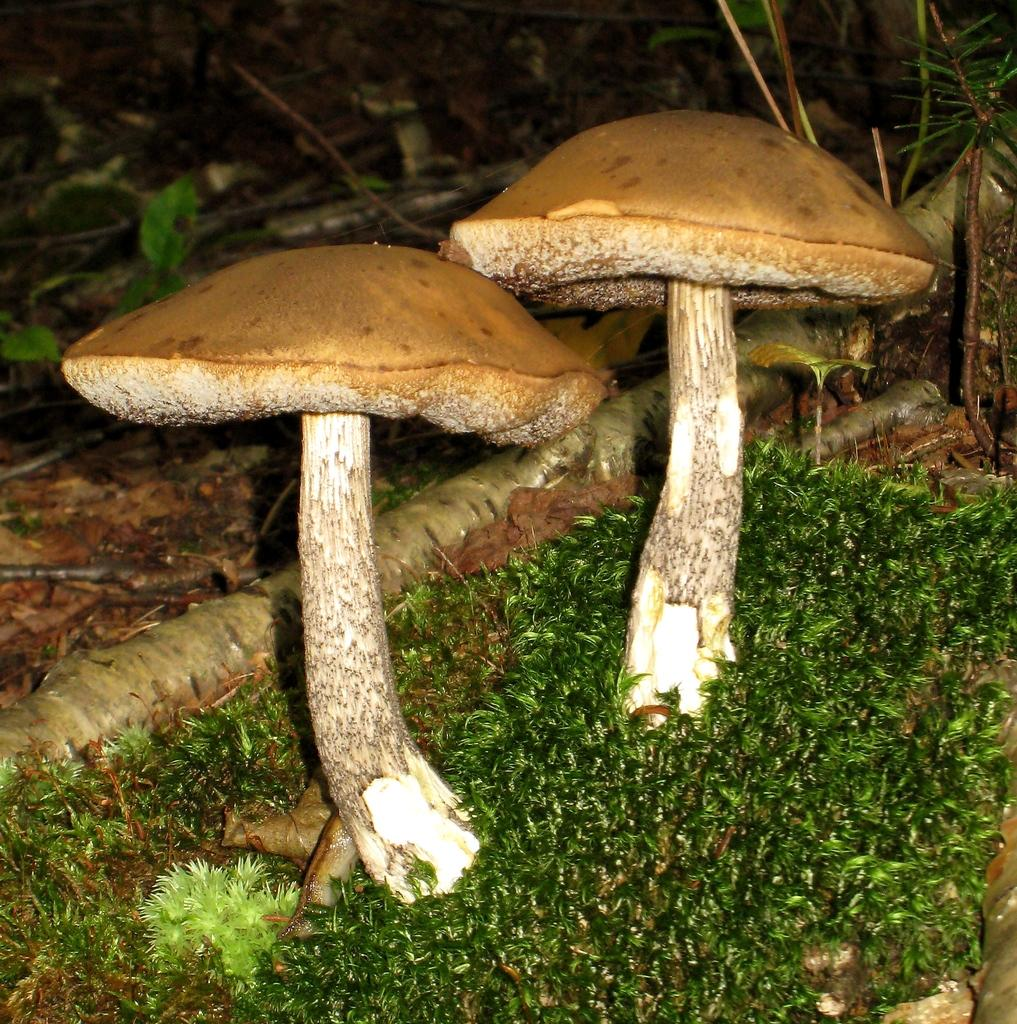How many mushrooms are present in the image? There are two mushrooms in the image. What can be found around the mushrooms? There are small leaves around the mushrooms. What is the name of the brother who is camping in the tent in the image? There is no brother or tent present in the image; it only features two mushrooms and small leaves. 